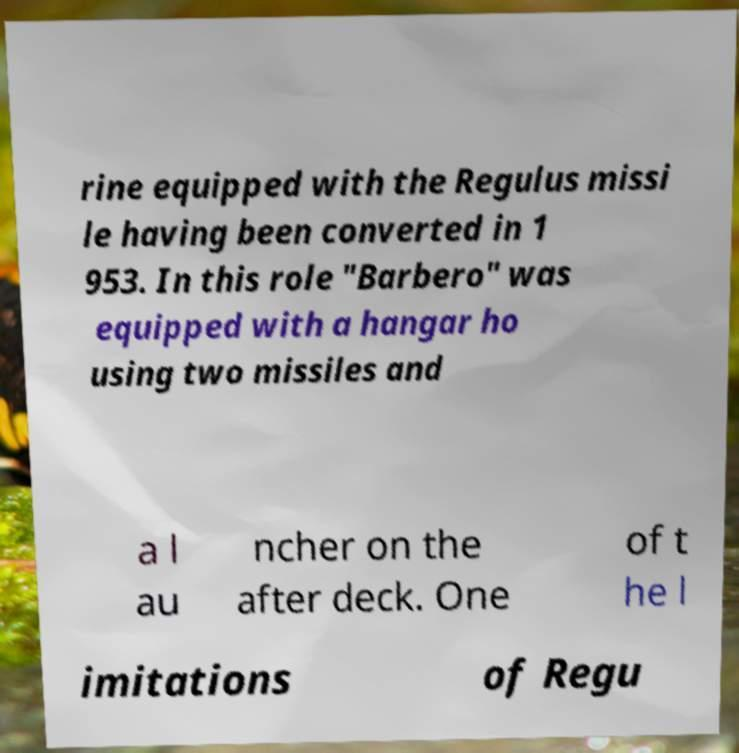Please identify and transcribe the text found in this image. rine equipped with the Regulus missi le having been converted in 1 953. In this role "Barbero" was equipped with a hangar ho using two missiles and a l au ncher on the after deck. One of t he l imitations of Regu 